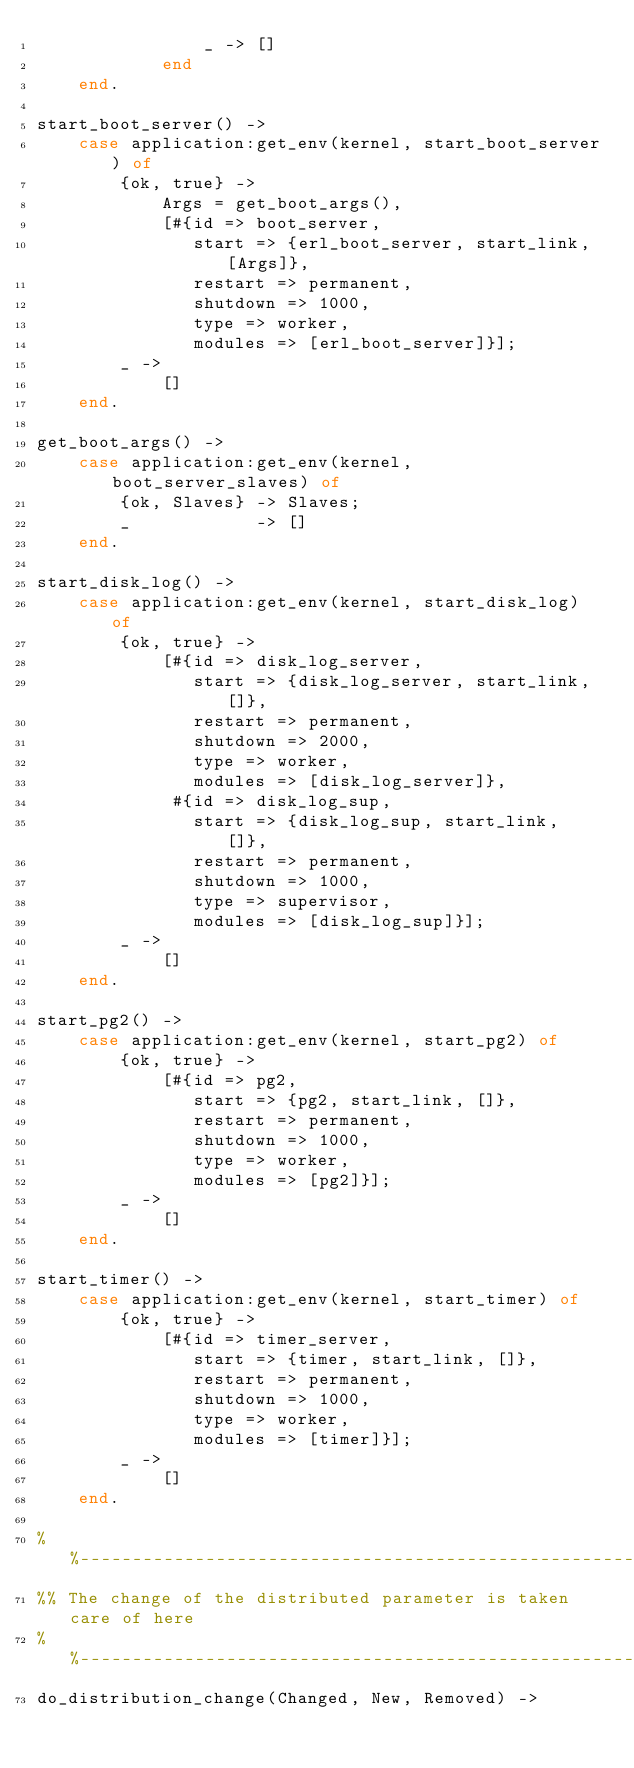Convert code to text. <code><loc_0><loc_0><loc_500><loc_500><_Erlang_>                _ -> []
            end
    end.

start_boot_server() ->
    case application:get_env(kernel, start_boot_server) of
        {ok, true} ->
            Args = get_boot_args(),
            [#{id => boot_server,
               start => {erl_boot_server, start_link, [Args]},
               restart => permanent,
               shutdown => 1000,
               type => worker,
               modules => [erl_boot_server]}];
        _ ->
            []
    end.

get_boot_args() ->
    case application:get_env(kernel, boot_server_slaves) of
        {ok, Slaves} -> Slaves;
        _            -> []
    end.

start_disk_log() ->
    case application:get_env(kernel, start_disk_log) of
        {ok, true} ->
            [#{id => disk_log_server,
               start => {disk_log_server, start_link, []},
               restart => permanent,
               shutdown => 2000,
               type => worker,
               modules => [disk_log_server]},
             #{id => disk_log_sup,
               start => {disk_log_sup, start_link, []},
               restart => permanent,
               shutdown => 1000,
               type => supervisor,
               modules => [disk_log_sup]}];
        _ ->
            []
    end.

start_pg2() ->
    case application:get_env(kernel, start_pg2) of
        {ok, true} ->
            [#{id => pg2,
               start => {pg2, start_link, []},
               restart => permanent,
               shutdown => 1000,
               type => worker,
               modules => [pg2]}];
        _ ->
            []
    end.

start_timer() ->
    case application:get_env(kernel, start_timer) of
        {ok, true} ->
            [#{id => timer_server,
               start => {timer, start_link, []},
               restart => permanent,
               shutdown => 1000,
               type => worker,
               modules => [timer]}];
        _ ->
            []
    end.

%%-----------------------------------------------------------------
%% The change of the distributed parameter is taken care of here
%%-----------------------------------------------------------------
do_distribution_change(Changed, New, Removed) -></code> 